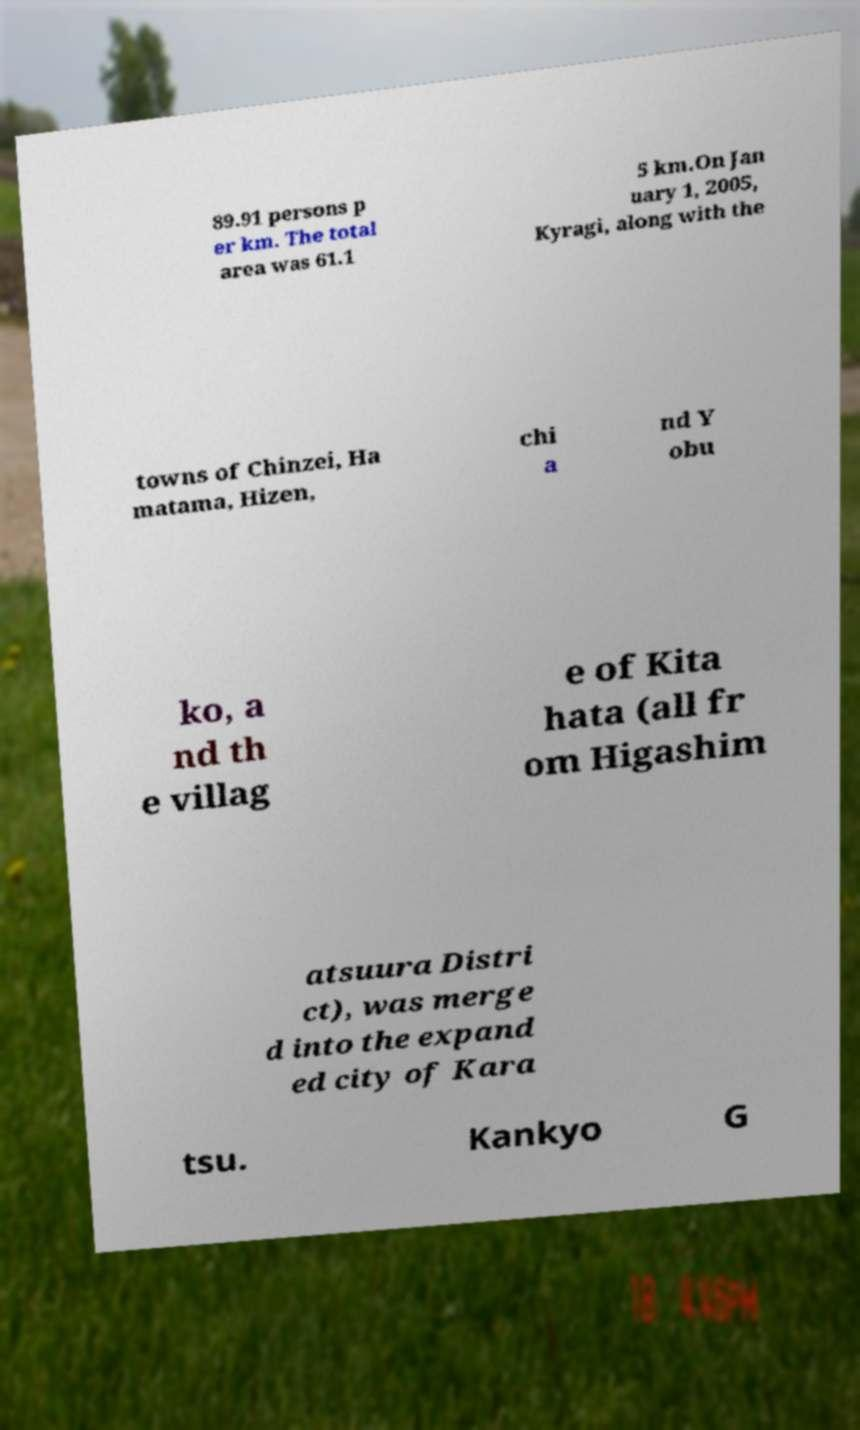What messages or text are displayed in this image? I need them in a readable, typed format. 89.91 persons p er km. The total area was 61.1 5 km.On Jan uary 1, 2005, Kyragi, along with the towns of Chinzei, Ha matama, Hizen, chi a nd Y obu ko, a nd th e villag e of Kita hata (all fr om Higashim atsuura Distri ct), was merge d into the expand ed city of Kara tsu. Kankyo G 